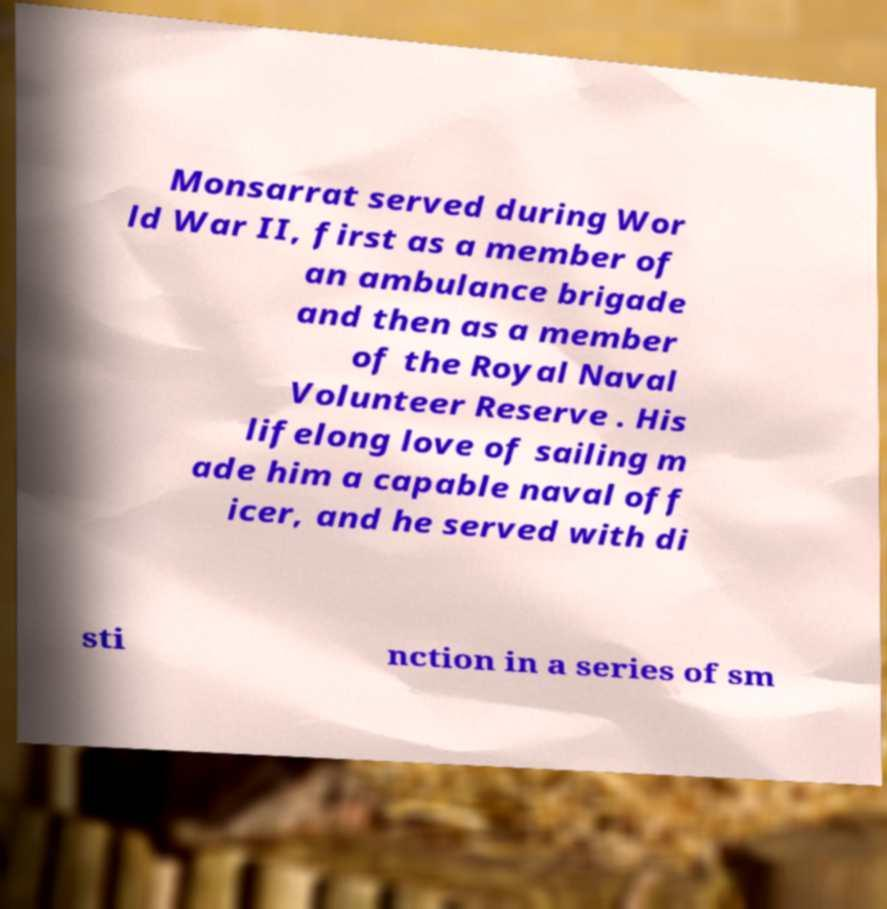Please read and relay the text visible in this image. What does it say? Monsarrat served during Wor ld War II, first as a member of an ambulance brigade and then as a member of the Royal Naval Volunteer Reserve . His lifelong love of sailing m ade him a capable naval off icer, and he served with di sti nction in a series of sm 